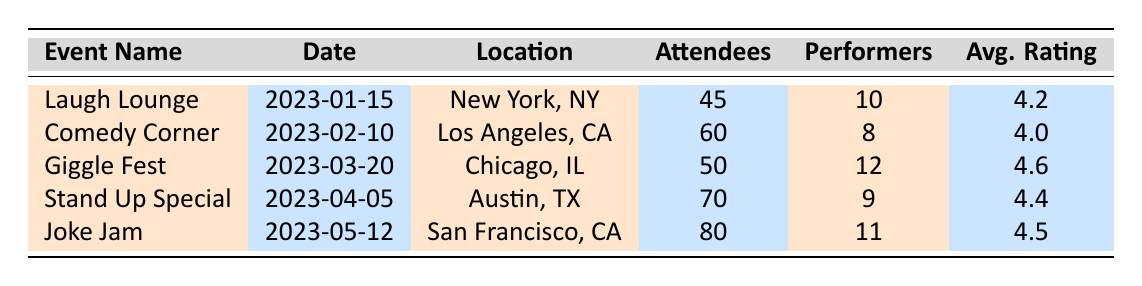What is the date of the "Laugh Lounge" event? The table lists the event "Laugh Lounge" under the "Event Name" column, which shows the date as "2023-01-15."
Answer: 2023-01-15 How many attendees were at the "Joke Jam" event? The table indicates that the event "Joke Jam" had 80 attendees listed in the "Attendees" column.
Answer: 80 Which event had the highest average rating? Looking at the "Avg. Rating" column, "Giggle Fest" has the highest average rating of 4.6 compared to other events.
Answer: Giggle Fest How many performers participated in the "Comedy Corner"? The number of performers for "Comedy Corner" is noted in the "Performers" column as 8.
Answer: 8 What is the average number of performers across all events? To find the average, sum the number of performers: (10 + 8 + 12 + 9 + 11 = 50). Divide by the number of events (5), which gives an average of 50/5 = 10.
Answer: 10 Is the average rating of "Stand Up Special" greater than 4.3? The "Avg. Rating" for "Stand Up Special" is 4.4, which is indeed greater than 4.3.
Answer: Yes What is the difference in attendee count between "Giggle Fest" and "Comedy Corner"? "Giggle Fest" has 50 attendees and "Comedy Corner" has 60 attendees. The difference is
Answer: 10 What is the total number of attendees across all events? Adding the attendees: (45 + 60 + 50 + 70 + 80 = 305). The total is 305 attendees across events.
Answer: 305 Which location had the event with the lowest average rating? By comparing average ratings, "Comedy Corner" has the lowest rating at 4.0, which corresponds to "Los Angeles, CA."
Answer: Los Angeles, CA How many events had an average rating of 4.4 or higher? The events with ratings of 4.4 or higher are "Giggle Fest" (4.6), "Stand Up Special" (4.4), and "Joke Jam" (4.5). Thus, there are 3 events.
Answer: 3 